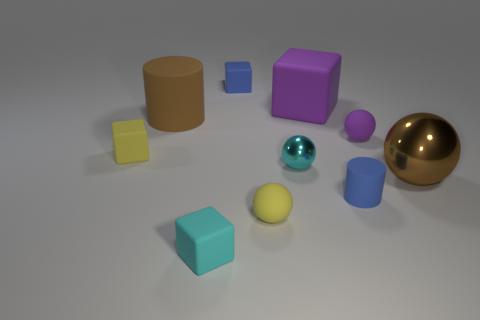How many yellow matte cubes are there?
Your answer should be compact. 1. Is the shape of the big purple thing the same as the tiny object that is behind the large matte block?
Make the answer very short. Yes. There is a cylinder left of the big purple cube; what is its size?
Offer a very short reply. Large. What is the blue cylinder made of?
Your answer should be very brief. Rubber. There is a tiny blue matte thing that is left of the tiny cyan shiny object; is it the same shape as the cyan metal thing?
Provide a short and direct response. No. What size is the matte object that is the same color as the tiny cylinder?
Your answer should be very brief. Small. Are there any brown balls of the same size as the yellow matte sphere?
Keep it short and to the point. No. Is there a rubber sphere that is on the left side of the blue object that is behind the matte cube on the right side of the yellow ball?
Give a very brief answer. No. There is a large block; is its color the same as the matte cylinder to the left of the yellow sphere?
Your answer should be very brief. No. There is a small cyan thing that is left of the small yellow rubber thing that is in front of the rubber object to the left of the brown rubber object; what is it made of?
Ensure brevity in your answer.  Rubber. 